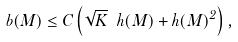<formula> <loc_0><loc_0><loc_500><loc_500>b ( M ) \leq C \left ( \sqrt { K } \ h ( M ) + h ( M ) ^ { 2 } \right ) ,</formula> 